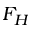<formula> <loc_0><loc_0><loc_500><loc_500>F _ { H }</formula> 